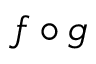<formula> <loc_0><loc_0><loc_500><loc_500>f \circ g</formula> 